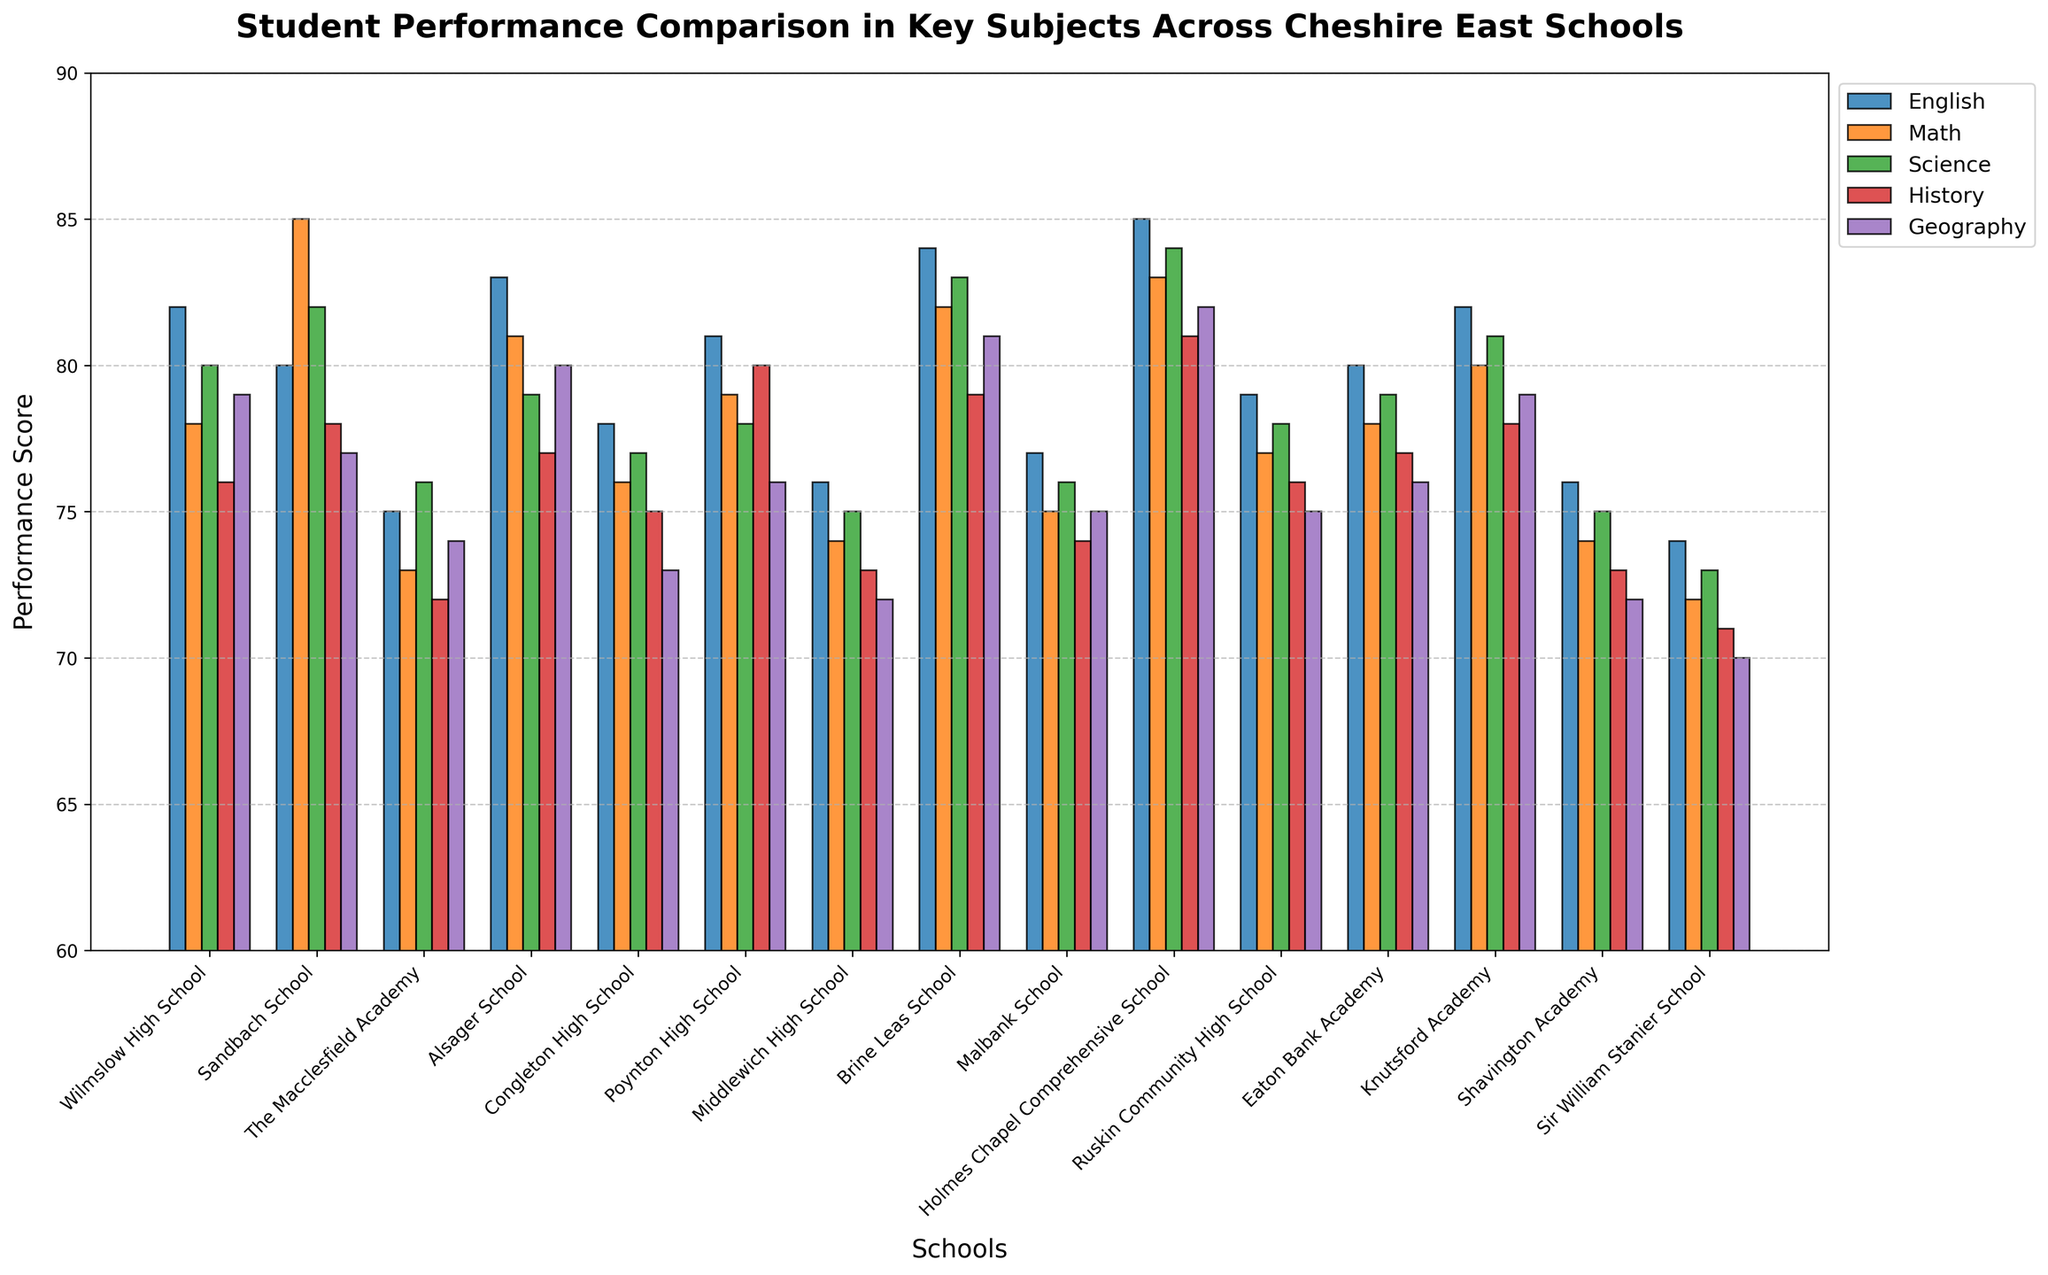Which school has the highest performance in English? The tallest bar representing English performance indicates the highest score. Holmes Chapel Comprehensive School has the highest English performance with a score of 85.
Answer: Holmes Chapel Comprehensive School Which subject has the lowest average score across all schools? To find the lowest average, sum the scores for all schools in each subject, then divide by the number of schools (15). Compare the averages for all subjects. Geography has the lowest average score.
Answer: Geography Which school has the smallest difference in performance between Math and Science? Calculate the absolute difference between Math and Science scores for each school and find the smallest value. Sandbach School has a difference of 3 (85 - 82 = 3).
Answer: Sandbach School What is the performance score range for History across all schools? To find the performance range, identify the highest and lowest scores in History and subtract the lowest from the highest. The highest is 81 (Holmes Chapel Comprehensive School), and the lowest is 71 (Sir William Stanier School). The range is 81 - 71 = 10.
Answer: 10 Which schools have a Geography performance score greater than 75? Compare the Geography scores for each school with 75. Alsager School (80), Wilmslow High School (79), Brine Leas School (81), Knutsford Academy (79), and Holmes Chapel Comprehensive School (82) have scores greater than 75.
Answer: Alsager School, Wilmslow High School, Brine Leas School, Knutsford Academy, Holmes Chapel Comprehensive School What is the average performance score for Wilmslow High School across all subjects? Sum the performance scores for all subjects for Wilmslow High School and divide by the number of subjects (5): (82 + 78 + 80 + 76 + 79) / 5 = 79.
Answer: 79 How does Brine Leas School compare to Malbank School in Science and Geography? Compare the performance scores for Brine Leas School and Malbank School in Science and Geography. Brine Leas outperforms Malbank in Science (83 vs. 76) and Geography (81 vs. 75).
Answer: Brine Leas performs better in both Science and Geography Which school has the highest performance in at least three subjects? Identify the school with the highest scores in three or more subjects. Holmes Chapel Comprehensive School has the highest scores in three subjects: English, Science, and Geography.
Answer: Holmes Chapel Comprehensive School What is the median performance score for Science across all schools? To find the median, order the Science scores from lowest to highest and identify the middle value. Ordered Science scores: 73, 75, 75, 76, 76, 76, 77, 78, 78, 78, 79, 80, 81, 82, 84. The median is the 8th value: 78.
Answer: 78 Which subjects does Poynton High School perform best and worst in? Compare the performance scores for all subjects at Poynton High School. The highest score is in History (80) and the lowest score is in Geography (76).
Answer: History (best), Geography (worst) 